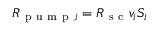Convert formula to latex. <formula><loc_0><loc_0><loc_500><loc_500>R _ { p u m p , i } = R _ { s c } v _ { i } S _ { i }</formula> 